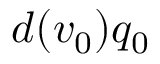<formula> <loc_0><loc_0><loc_500><loc_500>d ( v _ { 0 } ) q _ { 0 }</formula> 